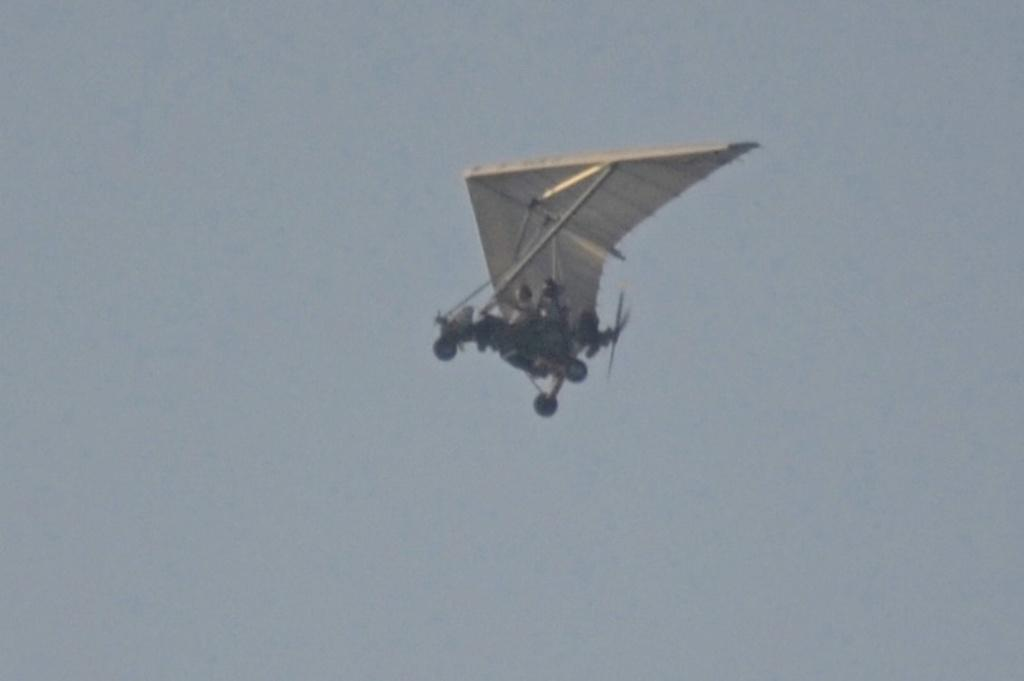What is the main subject of the image? The main subject of the image is an aircraft. What can be seen in the background of the image? The sky is visible in the background of the image. What letter is being written in the stomach of the aircraft in the image? There is no letter being written in the stomach of the aircraft, as aircraft do not have stomachs. 